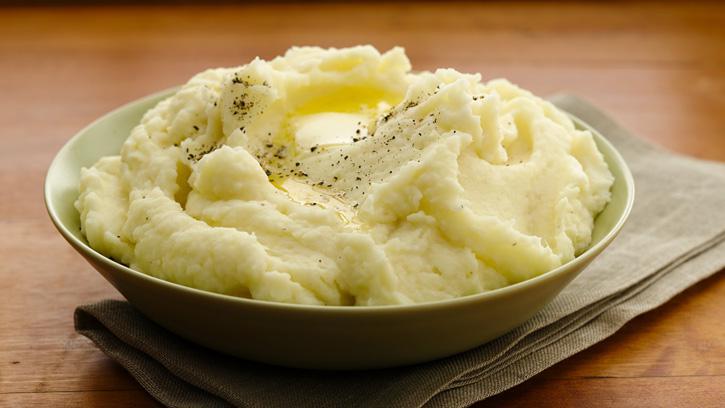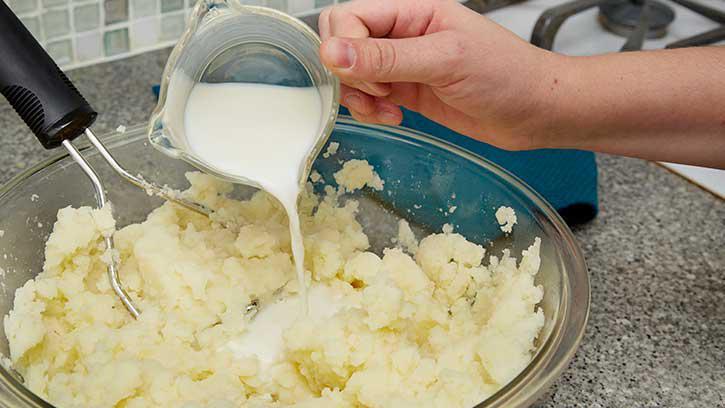The first image is the image on the left, the second image is the image on the right. Assess this claim about the two images: "A metal kitchen utinsil is sitting in a bowl of potatoes.". Correct or not? Answer yes or no. Yes. The first image is the image on the left, the second image is the image on the right. Examine the images to the left and right. Is the description "An image shows a bowl of potatoes with a metal potato masher sticking out." accurate? Answer yes or no. Yes. 